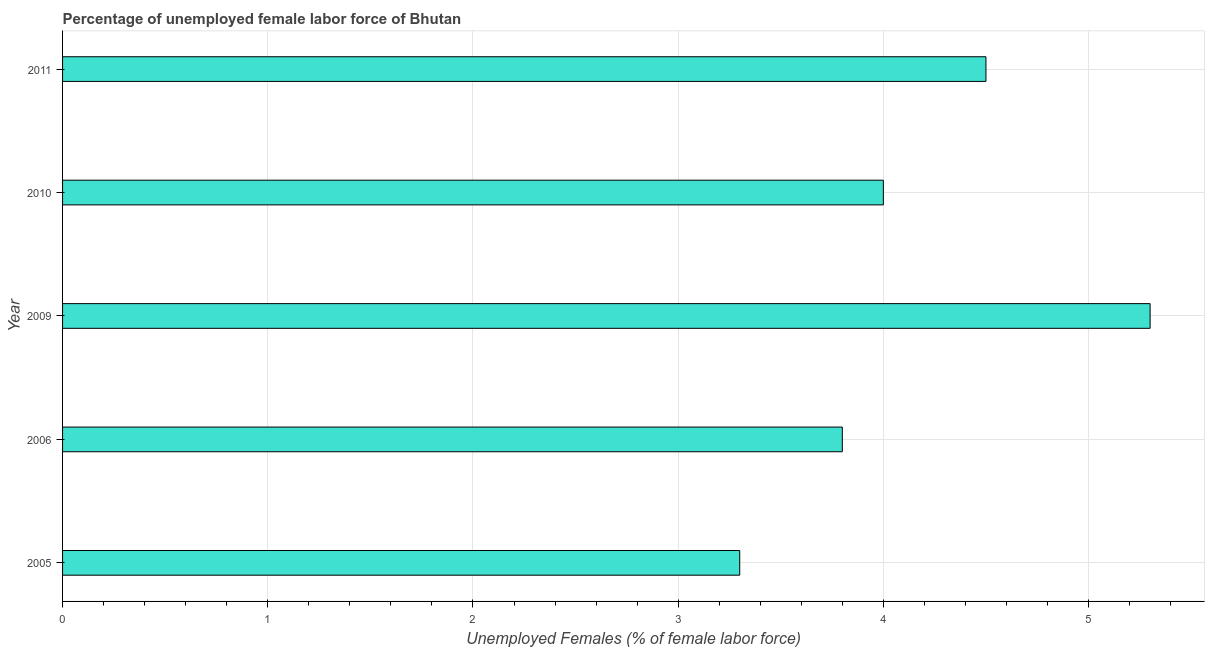Does the graph contain any zero values?
Give a very brief answer. No. What is the title of the graph?
Your answer should be very brief. Percentage of unemployed female labor force of Bhutan. What is the label or title of the X-axis?
Your answer should be compact. Unemployed Females (% of female labor force). What is the label or title of the Y-axis?
Offer a very short reply. Year. What is the total unemployed female labour force in 2006?
Your answer should be very brief. 3.8. Across all years, what is the maximum total unemployed female labour force?
Give a very brief answer. 5.3. Across all years, what is the minimum total unemployed female labour force?
Keep it short and to the point. 3.3. What is the sum of the total unemployed female labour force?
Ensure brevity in your answer.  20.9. What is the average total unemployed female labour force per year?
Keep it short and to the point. 4.18. In how many years, is the total unemployed female labour force greater than 1.6 %?
Provide a succinct answer. 5. What is the ratio of the total unemployed female labour force in 2005 to that in 2011?
Offer a very short reply. 0.73. What is the difference between the highest and the second highest total unemployed female labour force?
Offer a terse response. 0.8. Is the sum of the total unemployed female labour force in 2005 and 2011 greater than the maximum total unemployed female labour force across all years?
Provide a succinct answer. Yes. What is the difference between the highest and the lowest total unemployed female labour force?
Give a very brief answer. 2. How many bars are there?
Make the answer very short. 5. Are all the bars in the graph horizontal?
Your answer should be compact. Yes. Are the values on the major ticks of X-axis written in scientific E-notation?
Offer a terse response. No. What is the Unemployed Females (% of female labor force) in 2005?
Your answer should be compact. 3.3. What is the Unemployed Females (% of female labor force) of 2006?
Offer a terse response. 3.8. What is the Unemployed Females (% of female labor force) of 2009?
Keep it short and to the point. 5.3. What is the difference between the Unemployed Females (% of female labor force) in 2005 and 2006?
Your response must be concise. -0.5. What is the difference between the Unemployed Females (% of female labor force) in 2005 and 2010?
Ensure brevity in your answer.  -0.7. What is the difference between the Unemployed Females (% of female labor force) in 2005 and 2011?
Provide a short and direct response. -1.2. What is the difference between the Unemployed Females (% of female labor force) in 2006 and 2009?
Provide a succinct answer. -1.5. What is the difference between the Unemployed Females (% of female labor force) in 2006 and 2010?
Offer a terse response. -0.2. What is the difference between the Unemployed Females (% of female labor force) in 2009 and 2010?
Make the answer very short. 1.3. What is the difference between the Unemployed Females (% of female labor force) in 2009 and 2011?
Keep it short and to the point. 0.8. What is the difference between the Unemployed Females (% of female labor force) in 2010 and 2011?
Your answer should be compact. -0.5. What is the ratio of the Unemployed Females (% of female labor force) in 2005 to that in 2006?
Offer a terse response. 0.87. What is the ratio of the Unemployed Females (% of female labor force) in 2005 to that in 2009?
Provide a short and direct response. 0.62. What is the ratio of the Unemployed Females (% of female labor force) in 2005 to that in 2010?
Give a very brief answer. 0.82. What is the ratio of the Unemployed Females (% of female labor force) in 2005 to that in 2011?
Your response must be concise. 0.73. What is the ratio of the Unemployed Females (% of female labor force) in 2006 to that in 2009?
Keep it short and to the point. 0.72. What is the ratio of the Unemployed Females (% of female labor force) in 2006 to that in 2010?
Provide a short and direct response. 0.95. What is the ratio of the Unemployed Females (% of female labor force) in 2006 to that in 2011?
Provide a succinct answer. 0.84. What is the ratio of the Unemployed Females (% of female labor force) in 2009 to that in 2010?
Give a very brief answer. 1.32. What is the ratio of the Unemployed Females (% of female labor force) in 2009 to that in 2011?
Keep it short and to the point. 1.18. What is the ratio of the Unemployed Females (% of female labor force) in 2010 to that in 2011?
Give a very brief answer. 0.89. 